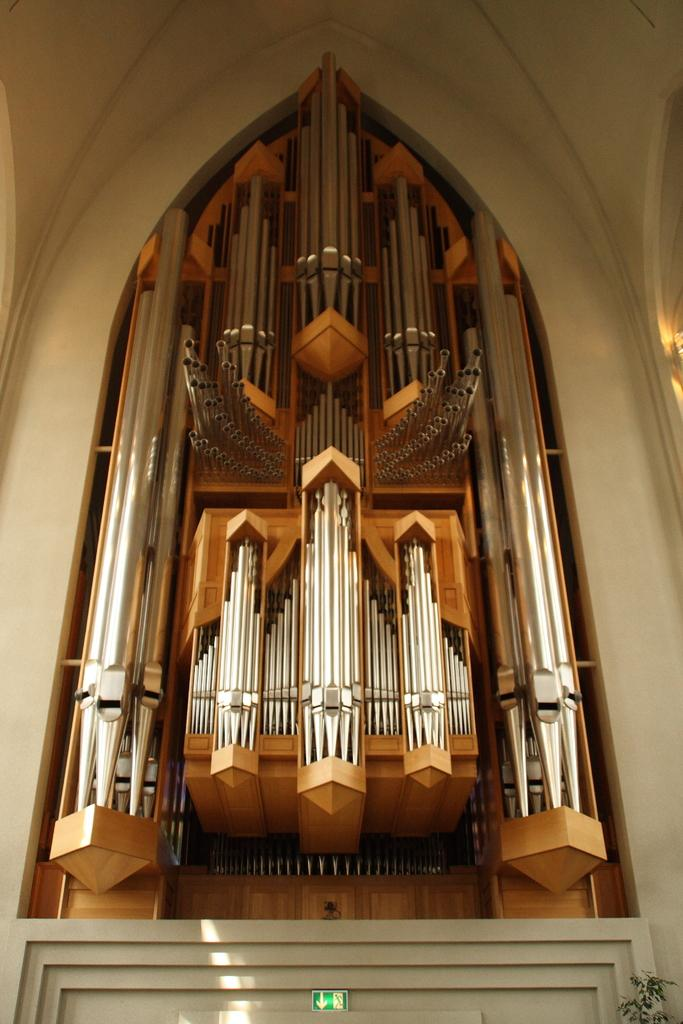What is located in the center of the image? There are objects in the center of the image. What type of material are the rods made of in the image? There are metal rods in the image. What can be seen in the background of the image? There is a wall in the background of the image. What is present at the bottom of the image? There is a sign board and a plant at the bottom of the image. What type of behavior do the cars exhibit in the image? There are no cars present in the image, so their behavior cannot be observed. How does the plant help the sail in the image? There is no sail present in the image, so the plant cannot interact with it. 